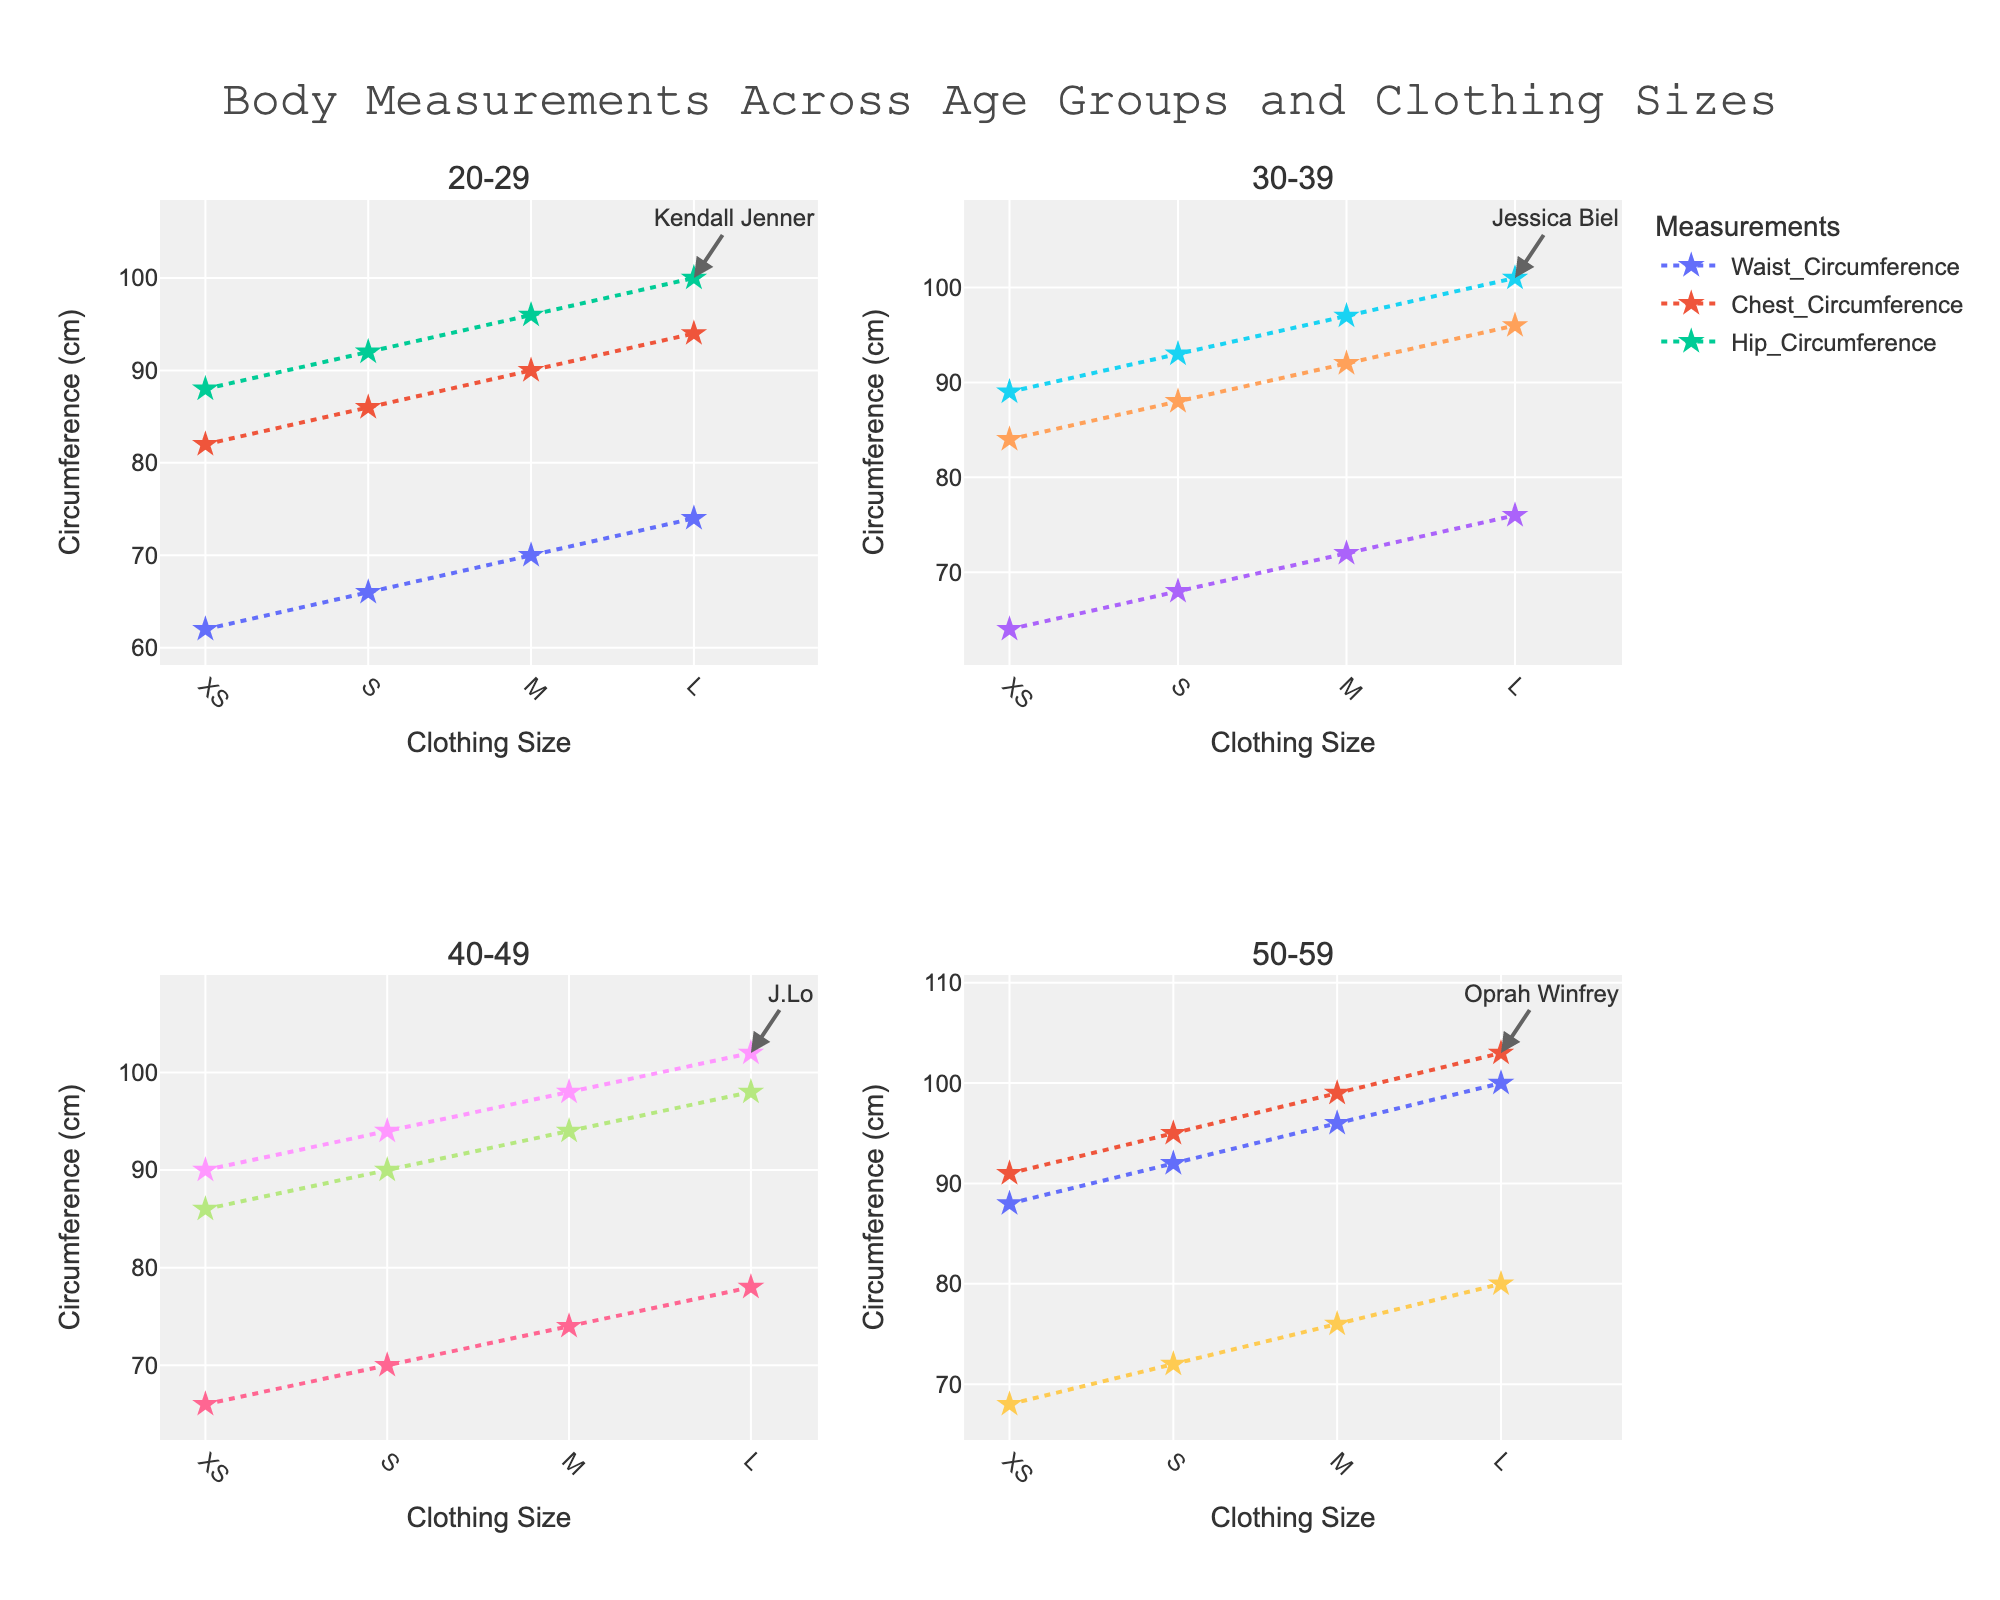How does the waist circumference change with clothing size in the 20-29 age group? To determine the waist circumference for each clothing size (XS, S, M, L) in the 20-29 age group, look at the subplot titled "20-29." The waist circumferences for XS, S, M, and L are represented by the first marker among the set of lines in this age group.
Answer: 62, 66, 70, 74 cm Which age group has the highest chest circumference for size M? Observe the plots for the chest circumference (second line in each subplot) for all age groups, focusing on the clothing size M. The highest chest circumference for size M is found at the highest value on the y-axis corresponding to size M across all subplots.
Answer: 96 cm (40-49 age group) What is the difference in hip circumference between size S and L in the 50-59 age group? Find the hip circumference values (third line in the 50-59 subplot) for clothing sizes S and L. The values are 95 cm for size S and 103 cm for size L. The difference is calculated as 103 cm - 95 cm.
Answer: 8 cm Who is the celebrity representation for clothing size L in the 30-39 age group? Look for the annotation in the subplot titled "30-39" that points to the L clothing size with a name. The name next to the marker for size L is the celebrity.
Answer: Jessica Biel How does the chest circumference vary among different clothing sizes in the 40-49 age group? Examine the chest circumference values for XS, S, M, and L in the 40-49 age group subplot. The chest circumferences are indicated by the second line in the plot. Read these values along the y-axis for each clothing size.
Answer: 86, 90, 94, 98 cm What is the trend in waist circumference from size XS to L in the 30-39 age group? Look at the waist circumference values in the 30-39 age group subplot, starting from XS to L, which are followed by the first line marked with stars. The trend can be described by observing the pattern of the increasing or decreasing values.
Answer: Increasing Which measurement shows the most significant variation across clothing sizes in the 20-29 age group? Compare the changes in waist circumference, chest circumference, and hip circumference across all clothing sizes in the 20-29 subplot. The line displaying the largest overall change in values indicates the most significant variation.
Answer: Hip circumference Compare the hip circumference between size XS in the 40-49 and 50-59 age groups. Find the value of hip circumference for size XS in the 40-49 age group subplot and compare it with the same size in the 50-59 age group subplot.
Answer: 90 cm (40-49), 91 cm (50-59) Who is the celebrity representation for the 40-49 age group size L, and what does this tell us about clothing size L in that age group? Identify the annotation pointing to size L in the 40-49 age group subplot. The name next to the marker provides the celebrity. Discuss what this representation might infer about the characteristics or appeal of size L.
Answer: J.Lo, it reflects that size L is modeled by a well-known and fashionable celebrity, potentially making size L aspirational for that age group 